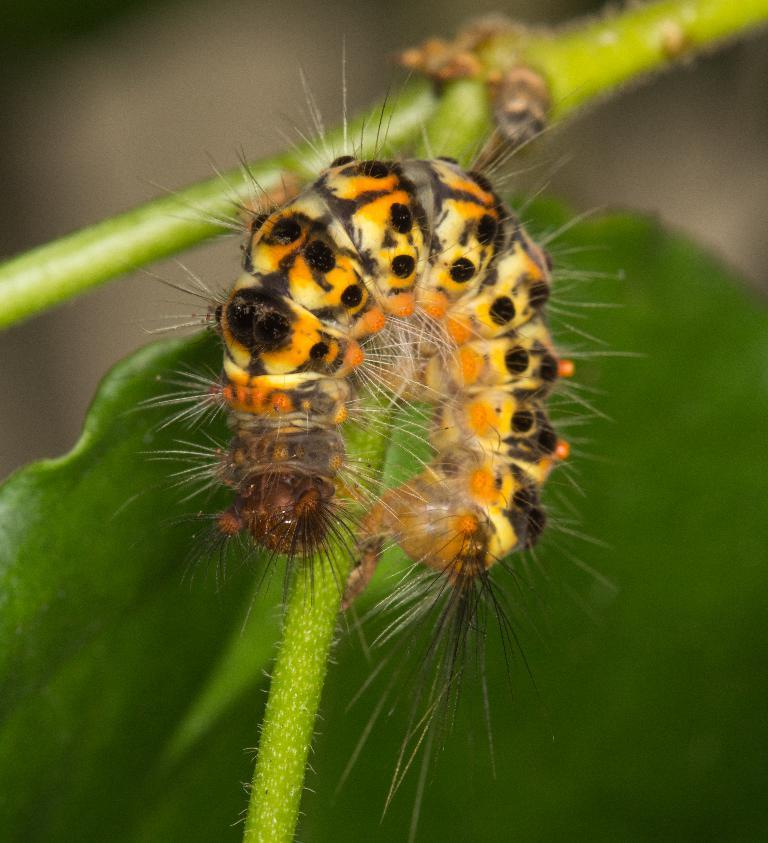What type of creature can be seen on the stem in the image? There is an insect on the stem in the image. What is located behind the insect in the image? There is a leaf behind the insect in the image. What type of structure can be seen in the image? There is no structure present in the image; it features an insect on a stem and a leaf. What religion is practiced by the insect in the image? There is no indication of any religious practice by the insect in the image, as insects do not have the ability to practice religion. 